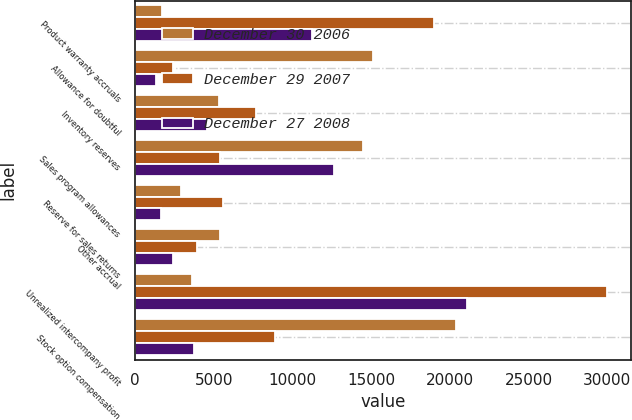Convert chart. <chart><loc_0><loc_0><loc_500><loc_500><stacked_bar_chart><ecel><fcel>Product warranty accruals<fcel>Allowance for doubtful<fcel>Inventory reserves<fcel>Sales program allowances<fcel>Reserve for sales returns<fcel>Other accrual<fcel>Unrealized intercompany profit<fcel>Stock option compensation<nl><fcel>December 30 2006<fcel>1696<fcel>15098<fcel>5331<fcel>14471<fcel>2914<fcel>5411<fcel>3601<fcel>20375<nl><fcel>December 29 2007<fcel>18975<fcel>2430<fcel>7699<fcel>5411<fcel>5565<fcel>3911<fcel>30006<fcel>8887<nl><fcel>December 27 2008<fcel>11259<fcel>1327<fcel>4555<fcel>12629<fcel>1660<fcel>2424<fcel>21115<fcel>3720<nl></chart> 